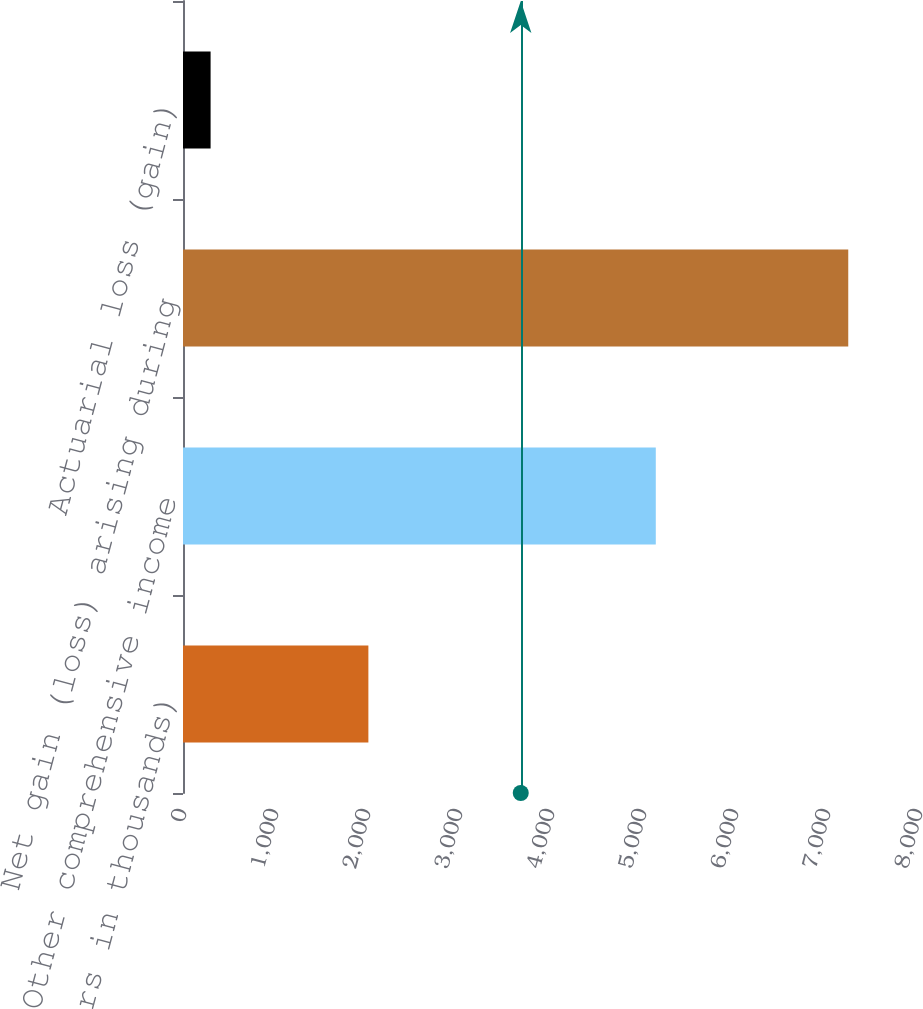Convert chart. <chart><loc_0><loc_0><loc_500><loc_500><bar_chart><fcel>(Dollars in thousands)<fcel>Other comprehensive income<fcel>Net gain (loss) arising during<fcel>Actuarial loss (gain)<nl><fcel>2015<fcel>5139<fcel>7231<fcel>300<nl></chart> 